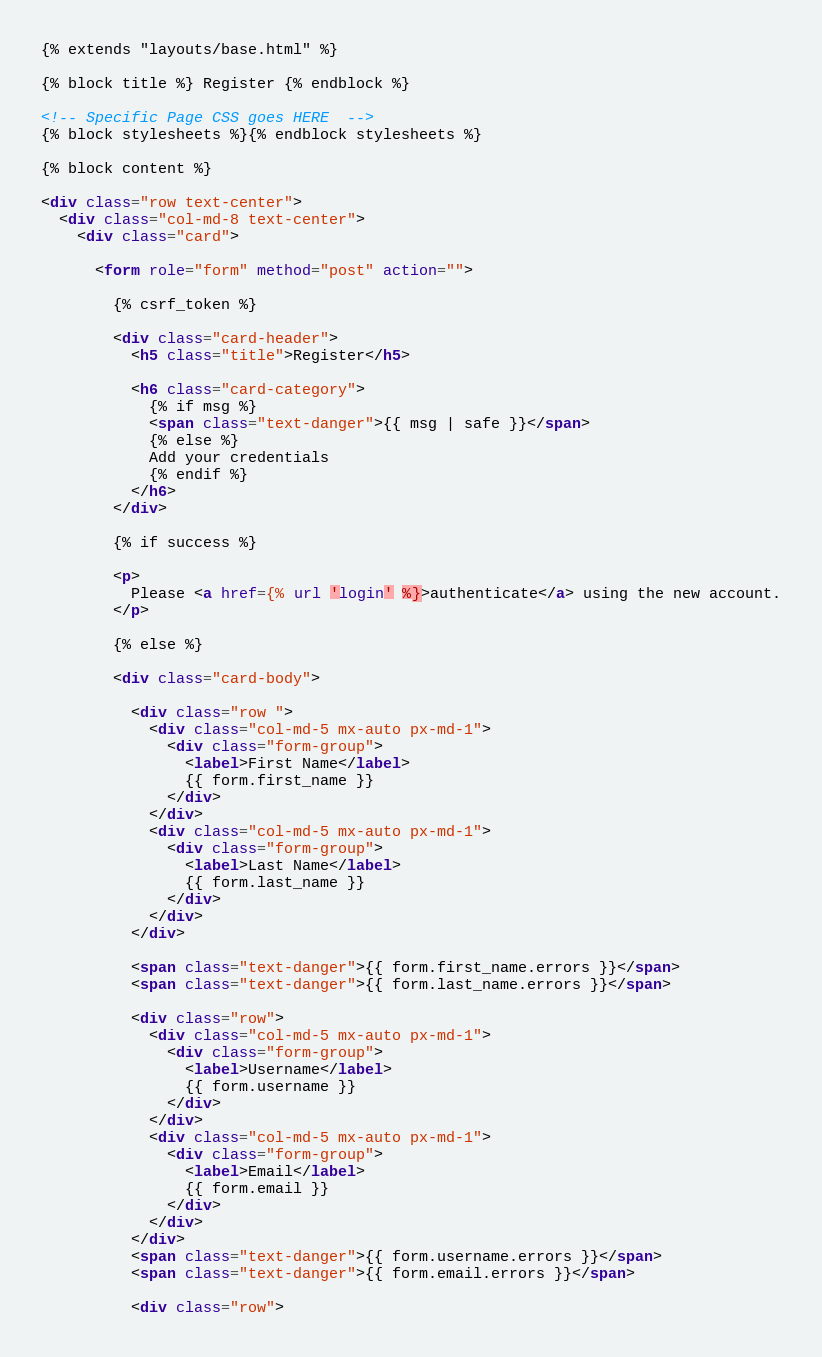<code> <loc_0><loc_0><loc_500><loc_500><_HTML_>{% extends "layouts/base.html" %}

{% block title %} Register {% endblock %}

<!-- Specific Page CSS goes HERE  -->
{% block stylesheets %}{% endblock stylesheets %}

{% block content %}

<div class="row text-center">
  <div class="col-md-8 text-center">
    <div class="card">

      <form role="form" method="post" action="">

        {% csrf_token %}

        <div class="card-header">
          <h5 class="title">Register</h5>

          <h6 class="card-category">
            {% if msg %}
            <span class="text-danger">{{ msg | safe }}</span>
            {% else %}
            Add your credentials
            {% endif %}
          </h6>
        </div>

        {% if success %}

        <p>
          Please <a href={% url 'login' %}>authenticate</a> using the new account.
        </p>

        {% else %}

        <div class="card-body">

          <div class="row ">
            <div class="col-md-5 mx-auto px-md-1">
              <div class="form-group">
                <label>First Name</label>
                {{ form.first_name }}
              </div>
            </div>
            <div class="col-md-5 mx-auto px-md-1">
              <div class="form-group">
                <label>Last Name</label>
                {{ form.last_name }}
              </div>
            </div>
          </div>

          <span class="text-danger">{{ form.first_name.errors }}</span>
          <span class="text-danger">{{ form.last_name.errors }}</span>

          <div class="row">
            <div class="col-md-5 mx-auto px-md-1">
              <div class="form-group">
                <label>Username</label>
                {{ form.username }}
              </div>
            </div>
            <div class="col-md-5 mx-auto px-md-1">
              <div class="form-group">
                <label>Email</label>
                {{ form.email }}
              </div>
            </div>
          </div>
          <span class="text-danger">{{ form.username.errors }}</span>
          <span class="text-danger">{{ form.email.errors }}</span>

          <div class="row"></code> 